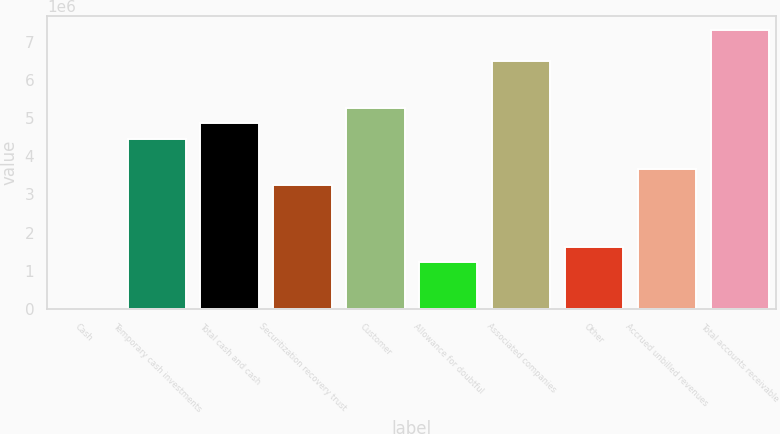Convert chart. <chart><loc_0><loc_0><loc_500><loc_500><bar_chart><fcel>Cash<fcel>Temporary cash investments<fcel>Total cash and cash<fcel>Securitization recovery trust<fcel>Customer<fcel>Allowance for doubtful<fcel>Associated companies<fcel>Other<fcel>Accrued unbilled revenues<fcel>Total accounts receivable<nl><fcel>150<fcel>4.46489e+06<fcel>4.87078e+06<fcel>3.24723e+06<fcel>5.27666e+06<fcel>1.21781e+06<fcel>6.49432e+06<fcel>1.62369e+06<fcel>3.65312e+06<fcel>7.30609e+06<nl></chart> 